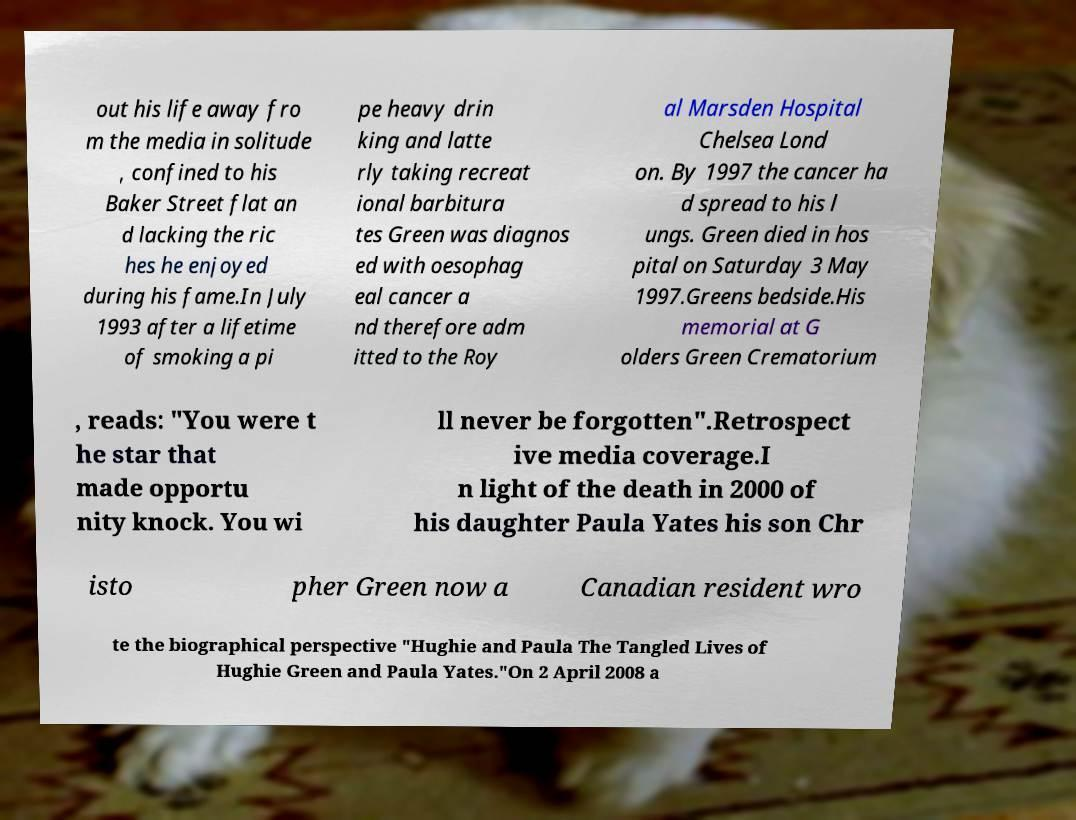Please identify and transcribe the text found in this image. out his life away fro m the media in solitude , confined to his Baker Street flat an d lacking the ric hes he enjoyed during his fame.In July 1993 after a lifetime of smoking a pi pe heavy drin king and latte rly taking recreat ional barbitura tes Green was diagnos ed with oesophag eal cancer a nd therefore adm itted to the Roy al Marsden Hospital Chelsea Lond on. By 1997 the cancer ha d spread to his l ungs. Green died in hos pital on Saturday 3 May 1997.Greens bedside.His memorial at G olders Green Crematorium , reads: "You were t he star that made opportu nity knock. You wi ll never be forgotten".Retrospect ive media coverage.I n light of the death in 2000 of his daughter Paula Yates his son Chr isto pher Green now a Canadian resident wro te the biographical perspective "Hughie and Paula The Tangled Lives of Hughie Green and Paula Yates."On 2 April 2008 a 